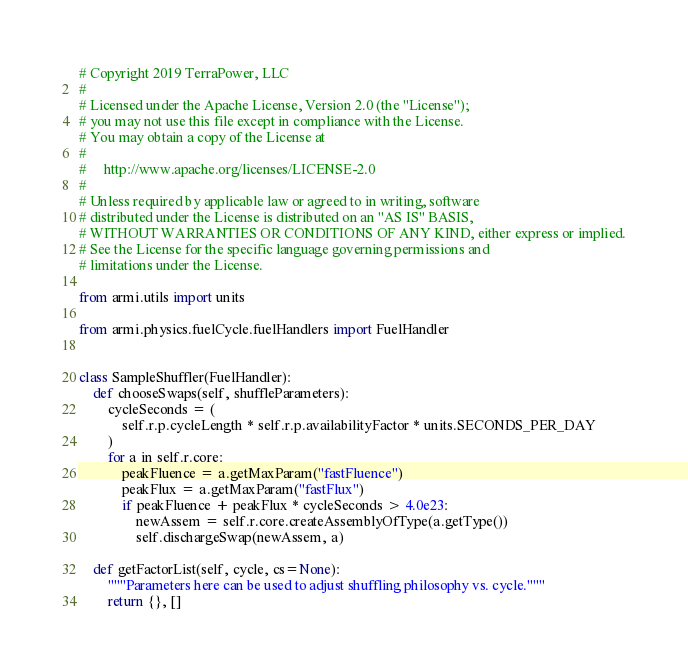Convert code to text. <code><loc_0><loc_0><loc_500><loc_500><_Python_># Copyright 2019 TerraPower, LLC
#
# Licensed under the Apache License, Version 2.0 (the "License");
# you may not use this file except in compliance with the License.
# You may obtain a copy of the License at
#
#     http://www.apache.org/licenses/LICENSE-2.0
#
# Unless required by applicable law or agreed to in writing, software
# distributed under the License is distributed on an "AS IS" BASIS,
# WITHOUT WARRANTIES OR CONDITIONS OF ANY KIND, either express or implied.
# See the License for the specific language governing permissions and
# limitations under the License.

from armi.utils import units

from armi.physics.fuelCycle.fuelHandlers import FuelHandler


class SampleShuffler(FuelHandler):
    def chooseSwaps(self, shuffleParameters):
        cycleSeconds = (
            self.r.p.cycleLength * self.r.p.availabilityFactor * units.SECONDS_PER_DAY
        )
        for a in self.r.core:
            peakFluence = a.getMaxParam("fastFluence")
            peakFlux = a.getMaxParam("fastFlux")
            if peakFluence + peakFlux * cycleSeconds > 4.0e23:
                newAssem = self.r.core.createAssemblyOfType(a.getType())
                self.dischargeSwap(newAssem, a)

    def getFactorList(self, cycle, cs=None):
        """Parameters here can be used to adjust shuffling philosophy vs. cycle."""
        return {}, []
</code> 